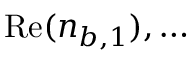Convert formula to latex. <formula><loc_0><loc_0><loc_500><loc_500>R e ( n _ { b , 1 } ) , \dots</formula> 